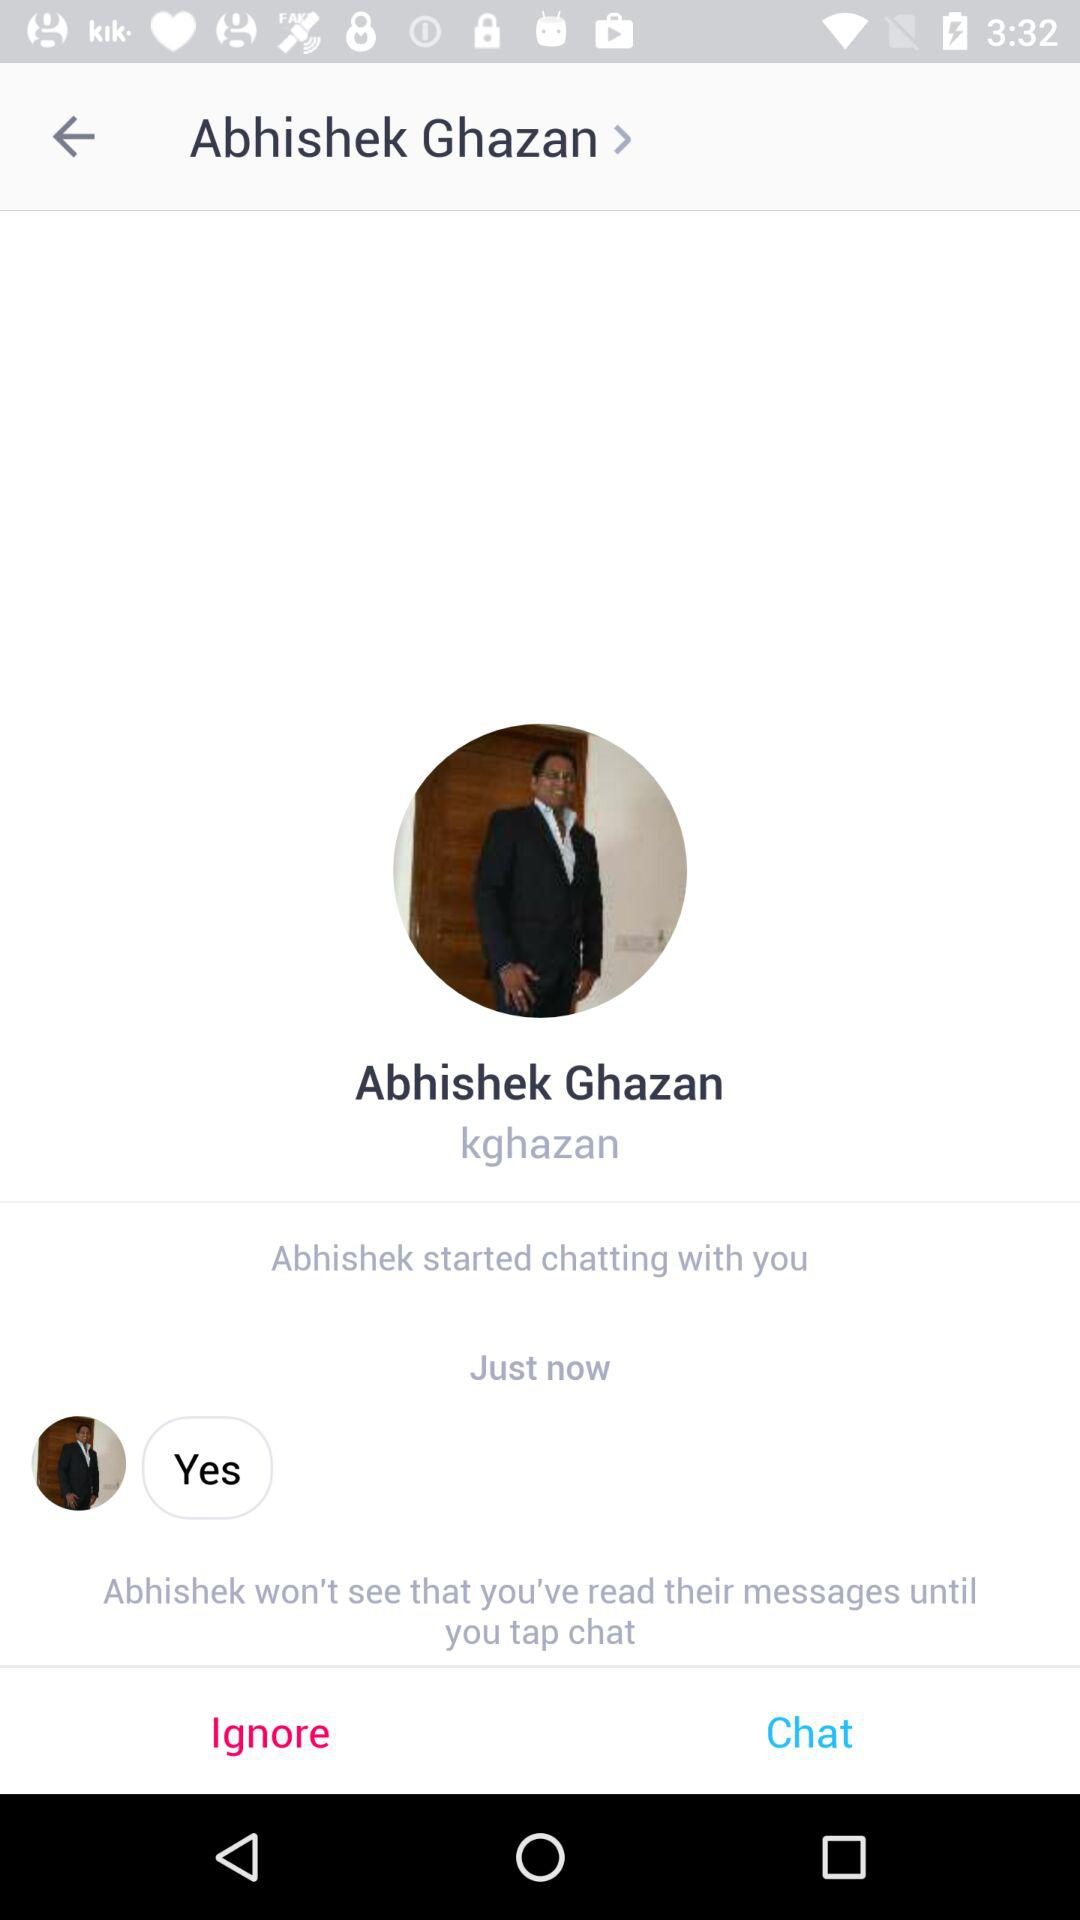What is the user name? The user name is Abhishek Ghazan. 